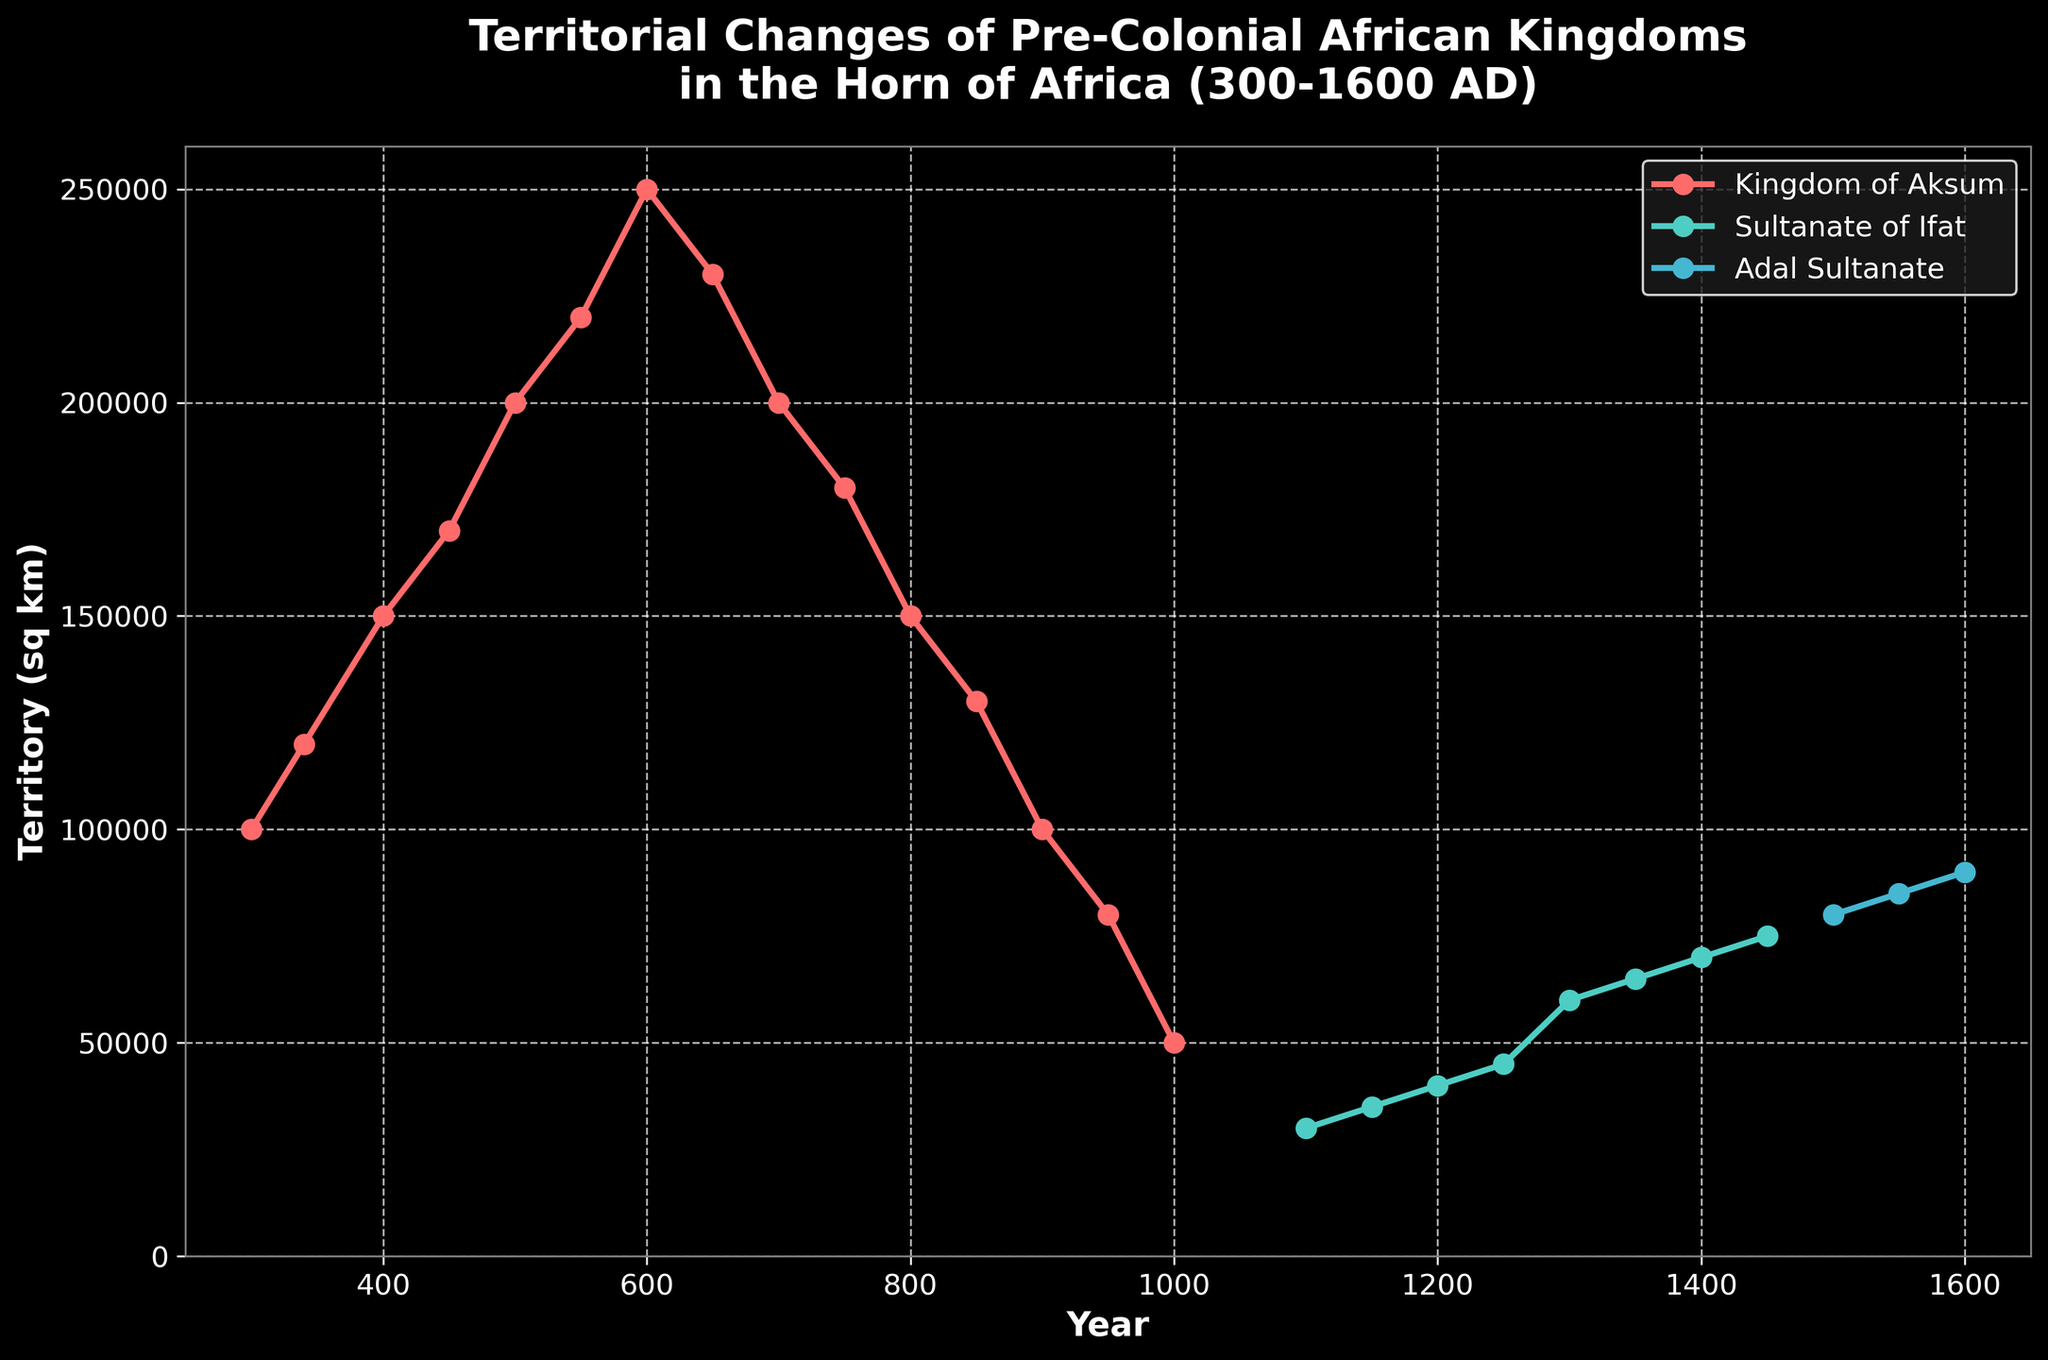What is the title of the plot? The title of the plot is usually located at the top and summarizes the figure's content. It provides an overview of what the figure represents.
Answer: 'Territorial Changes of Pre-Colonial African Kingdoms in the Horn of Africa (300-1600 AD)' How many distinct kingdoms are represented in the plot? We can identify this by looking at the legend, which lists each kingdom and its corresponding line color.
Answer: 3 What kingdom had the largest territorial area in 600 AD? By locating the year 600 on the x-axis and following the corresponding data points for territorial size, we identify the largest value.
Answer: Kingdom of Aksum Between which years did the Kingdom of Aksum experience a consistent decrease in territory? Following the plot line for the Kingdom of Aksum, we look for a consistent downward slope.
Answer: Between 600 AD and 950 AD At what year did the Sultanate of Ifat have a territory size of 60,000 sq km? By following the Sultanate of Ifat's line to where it intersects the 60,000 sq km mark on the y-axis, we find the corresponding year on the x-axis.
Answer: 1300 AD Which kingdom showed an increasing trend in territorial size in its entire visible period? By observing the lines for all the kingdoms and identifying which line consistently slopes upward throughout its duration.
Answer: Adal Sultanate How does the territory size of the Sultanate of Ifat in 1100 AD compare to its size in 1450 AD? We look at the data points for Sultanate of Ifat at 1100 AD and 1450 AD and compare their y-axis values.
Answer: It increased from 30,000 sq km to 75,000 sq km What was the approximate decrease in territory size for the Kingdom of Aksum from its peak in 600 AD to 800 AD? First, calculate the peak value in 600 AD, then subtract the value in 800 AD to find the decrease.
Answer: Approx. 100,000 sq km (250,000 - 150,000) Which kingdom had territories in the smallest range of sizes during its documented period? Assess each kingdom's maximum and minimum territory sizes and determine which range is the smallest.
Answer: Sultanate of Ifat (range 30,000 - 75,000 sq km) How did the territory of the Kingdom of Aksum change between 900 AD and 1000 AD? Observe the territory sizes at 900 AD and 1000 AD and describe the change.
Answer: It decreased from 100,000 sq km to 50,000 sq km What is the maximum territory size achieved by any kingdom depicted in the figure? Look for the highest point on the y-axis that any of the lines reach.
Answer: 250,000 sq km 